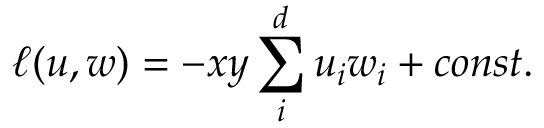<formula> <loc_0><loc_0><loc_500><loc_500>\ell ( u , w ) = - { x y } \sum _ { i } ^ { d } u _ { i } w _ { i } + c o n s t .</formula> 